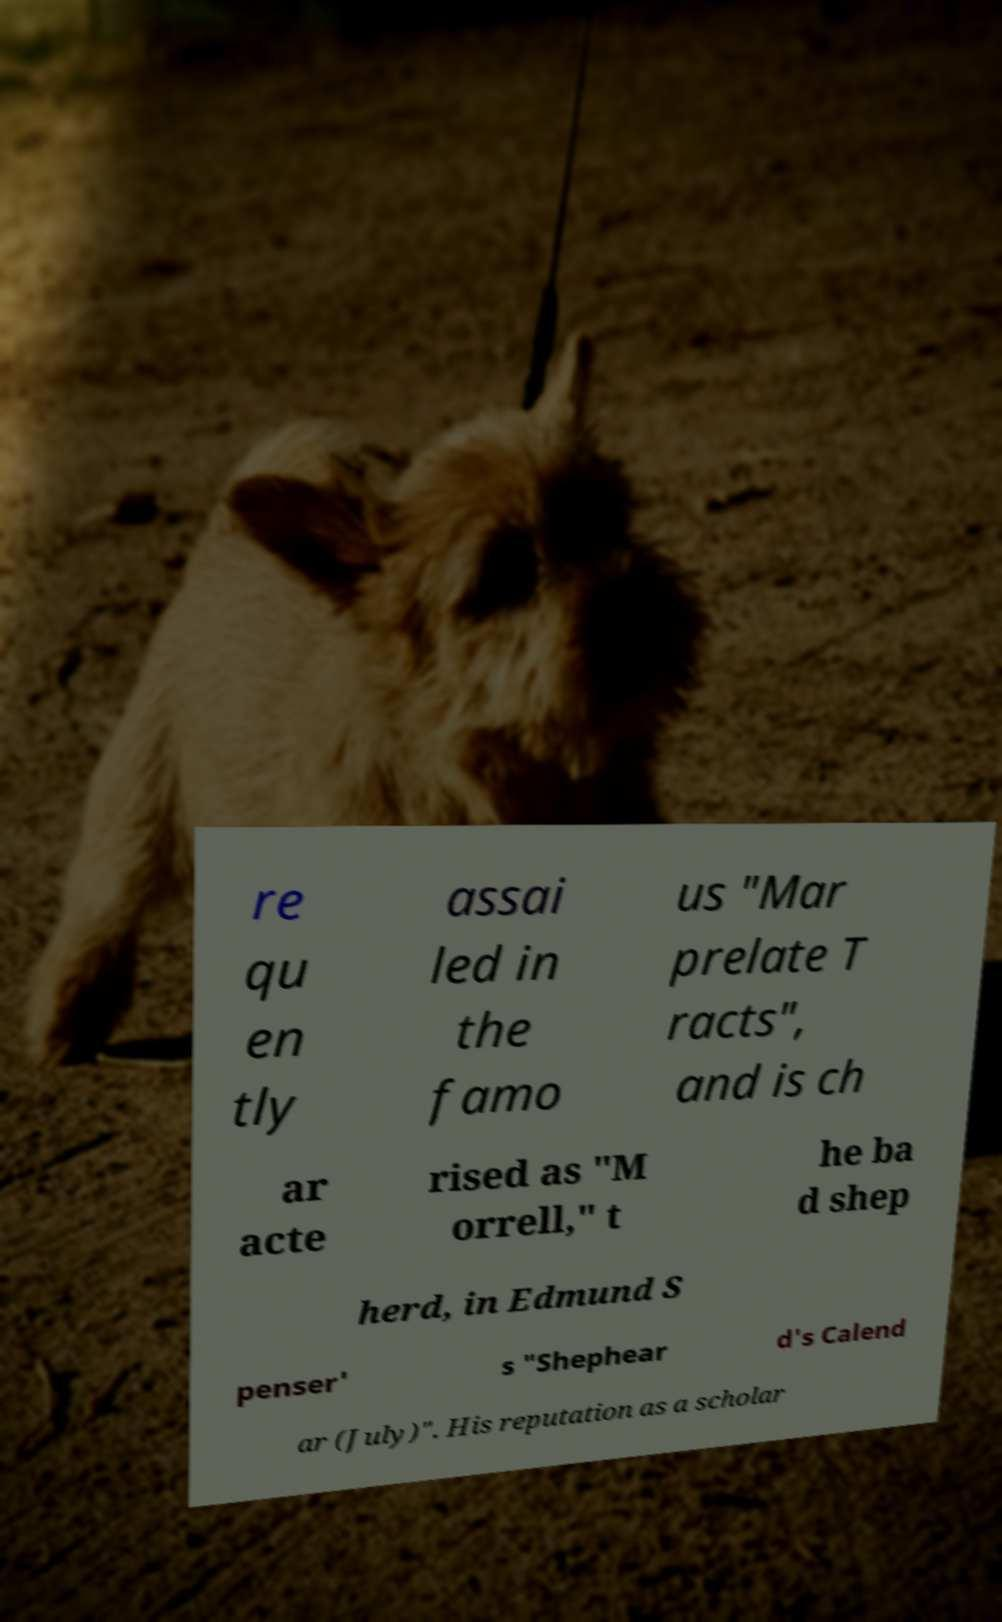Can you read and provide the text displayed in the image?This photo seems to have some interesting text. Can you extract and type it out for me? re qu en tly assai led in the famo us "Mar prelate T racts", and is ch ar acte rised as "M orrell," t he ba d shep herd, in Edmund S penser' s "Shephear d's Calend ar (July)". His reputation as a scholar 